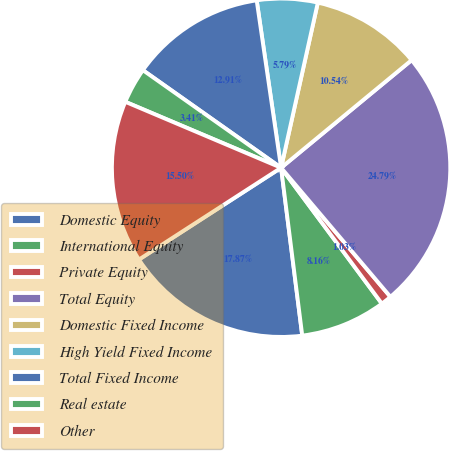Convert chart. <chart><loc_0><loc_0><loc_500><loc_500><pie_chart><fcel>Domestic Equity<fcel>International Equity<fcel>Private Equity<fcel>Total Equity<fcel>Domestic Fixed Income<fcel>High Yield Fixed Income<fcel>Total Fixed Income<fcel>Real estate<fcel>Other<nl><fcel>17.87%<fcel>8.16%<fcel>1.03%<fcel>24.79%<fcel>10.54%<fcel>5.79%<fcel>12.91%<fcel>3.41%<fcel>15.5%<nl></chart> 